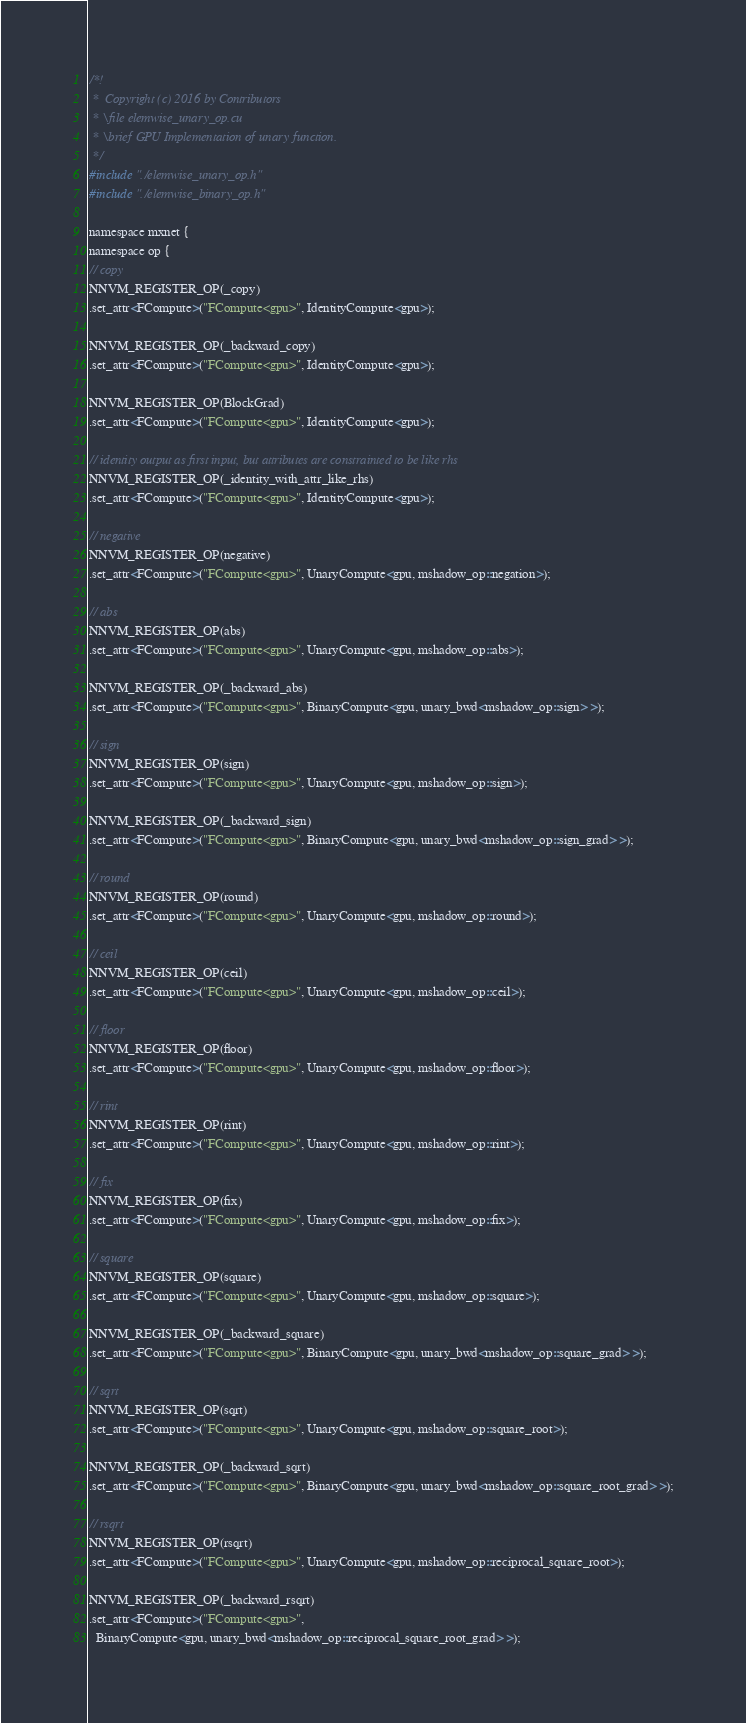Convert code to text. <code><loc_0><loc_0><loc_500><loc_500><_Cuda_>/*!
 *  Copyright (c) 2016 by Contributors
 * \file elemwise_unary_op.cu
 * \brief GPU Implementation of unary function.
 */
#include "./elemwise_unary_op.h"
#include "./elemwise_binary_op.h"

namespace mxnet {
namespace op {
// copy
NNVM_REGISTER_OP(_copy)
.set_attr<FCompute>("FCompute<gpu>", IdentityCompute<gpu>);

NNVM_REGISTER_OP(_backward_copy)
.set_attr<FCompute>("FCompute<gpu>", IdentityCompute<gpu>);

NNVM_REGISTER_OP(BlockGrad)
.set_attr<FCompute>("FCompute<gpu>", IdentityCompute<gpu>);

// identity output as first input, but attributes are constrainted to be like rhs
NNVM_REGISTER_OP(_identity_with_attr_like_rhs)
.set_attr<FCompute>("FCompute<gpu>", IdentityCompute<gpu>);

// negative
NNVM_REGISTER_OP(negative)
.set_attr<FCompute>("FCompute<gpu>", UnaryCompute<gpu, mshadow_op::negation>);

// abs
NNVM_REGISTER_OP(abs)
.set_attr<FCompute>("FCompute<gpu>", UnaryCompute<gpu, mshadow_op::abs>);

NNVM_REGISTER_OP(_backward_abs)
.set_attr<FCompute>("FCompute<gpu>", BinaryCompute<gpu, unary_bwd<mshadow_op::sign> >);

// sign
NNVM_REGISTER_OP(sign)
.set_attr<FCompute>("FCompute<gpu>", UnaryCompute<gpu, mshadow_op::sign>);

NNVM_REGISTER_OP(_backward_sign)
.set_attr<FCompute>("FCompute<gpu>", BinaryCompute<gpu, unary_bwd<mshadow_op::sign_grad> >);

// round
NNVM_REGISTER_OP(round)
.set_attr<FCompute>("FCompute<gpu>", UnaryCompute<gpu, mshadow_op::round>);

// ceil
NNVM_REGISTER_OP(ceil)
.set_attr<FCompute>("FCompute<gpu>", UnaryCompute<gpu, mshadow_op::ceil>);

// floor
NNVM_REGISTER_OP(floor)
.set_attr<FCompute>("FCompute<gpu>", UnaryCompute<gpu, mshadow_op::floor>);

// rint
NNVM_REGISTER_OP(rint)
.set_attr<FCompute>("FCompute<gpu>", UnaryCompute<gpu, mshadow_op::rint>);

// fix
NNVM_REGISTER_OP(fix)
.set_attr<FCompute>("FCompute<gpu>", UnaryCompute<gpu, mshadow_op::fix>);

// square
NNVM_REGISTER_OP(square)
.set_attr<FCompute>("FCompute<gpu>", UnaryCompute<gpu, mshadow_op::square>);

NNVM_REGISTER_OP(_backward_square)
.set_attr<FCompute>("FCompute<gpu>", BinaryCompute<gpu, unary_bwd<mshadow_op::square_grad> >);

// sqrt
NNVM_REGISTER_OP(sqrt)
.set_attr<FCompute>("FCompute<gpu>", UnaryCompute<gpu, mshadow_op::square_root>);

NNVM_REGISTER_OP(_backward_sqrt)
.set_attr<FCompute>("FCompute<gpu>", BinaryCompute<gpu, unary_bwd<mshadow_op::square_root_grad> >);

// rsqrt
NNVM_REGISTER_OP(rsqrt)
.set_attr<FCompute>("FCompute<gpu>", UnaryCompute<gpu, mshadow_op::reciprocal_square_root>);

NNVM_REGISTER_OP(_backward_rsqrt)
.set_attr<FCompute>("FCompute<gpu>",
  BinaryCompute<gpu, unary_bwd<mshadow_op::reciprocal_square_root_grad> >);
</code> 